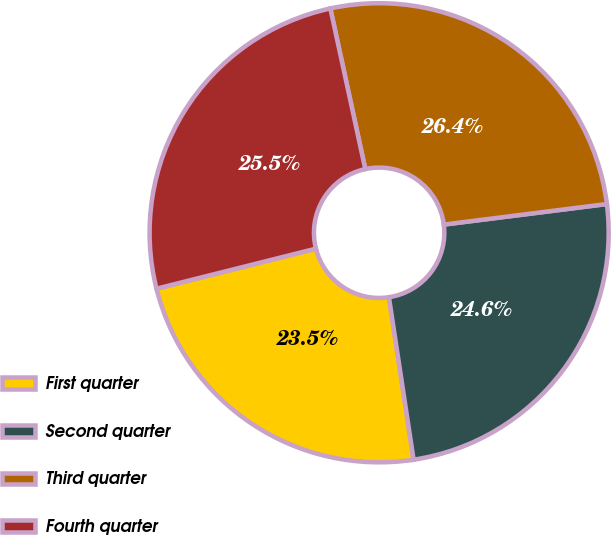Convert chart. <chart><loc_0><loc_0><loc_500><loc_500><pie_chart><fcel>First quarter<fcel>Second quarter<fcel>Third quarter<fcel>Fourth quarter<nl><fcel>23.48%<fcel>24.6%<fcel>26.41%<fcel>25.51%<nl></chart> 